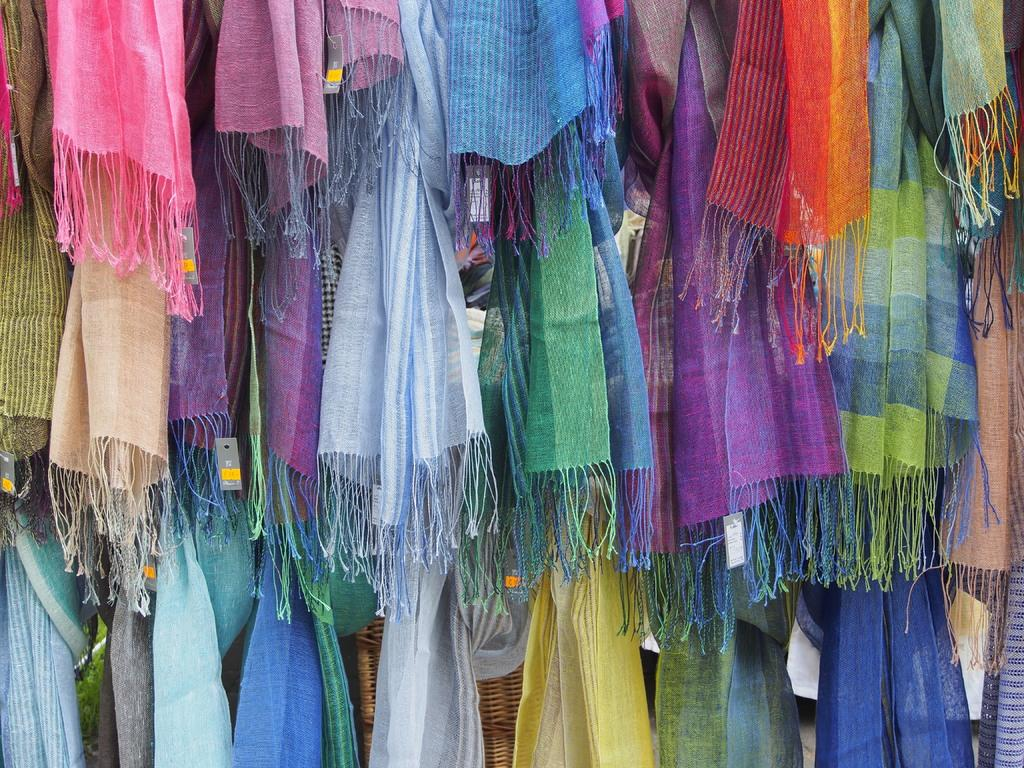What type of items can be seen in the image? There are clothes in the image. Are there any additional features on the clothes? Yes, there are tags in the image. What direction is the wine flowing in the image? There is no wine present in the image. How does the increase in the number of clothes affect the tags in the image? There is no indication of an increase in the number of clothes or any effect on the tags in the image. 